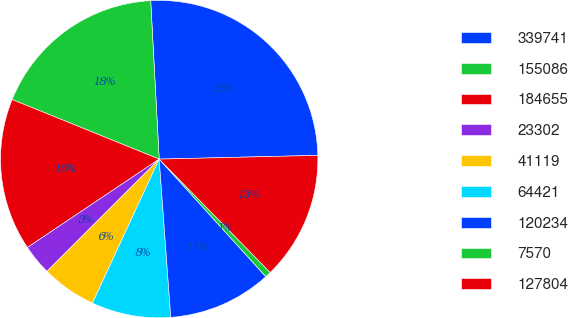<chart> <loc_0><loc_0><loc_500><loc_500><pie_chart><fcel>339741<fcel>155086<fcel>184655<fcel>23302<fcel>41119<fcel>64421<fcel>120234<fcel>7570<fcel>127804<nl><fcel>25.48%<fcel>18.02%<fcel>15.53%<fcel>3.1%<fcel>5.59%<fcel>8.07%<fcel>10.56%<fcel>0.61%<fcel>13.04%<nl></chart> 